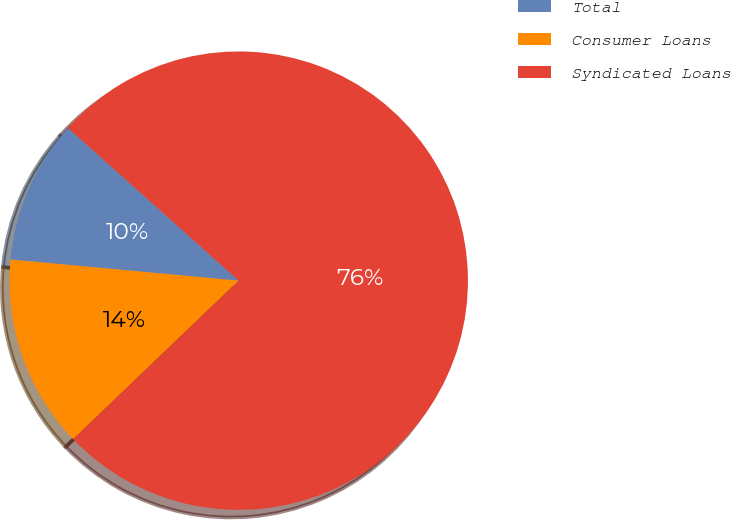Convert chart. <chart><loc_0><loc_0><loc_500><loc_500><pie_chart><fcel>Total<fcel>Consumer Loans<fcel>Syndicated Loans<nl><fcel>10.14%<fcel>13.63%<fcel>76.23%<nl></chart> 